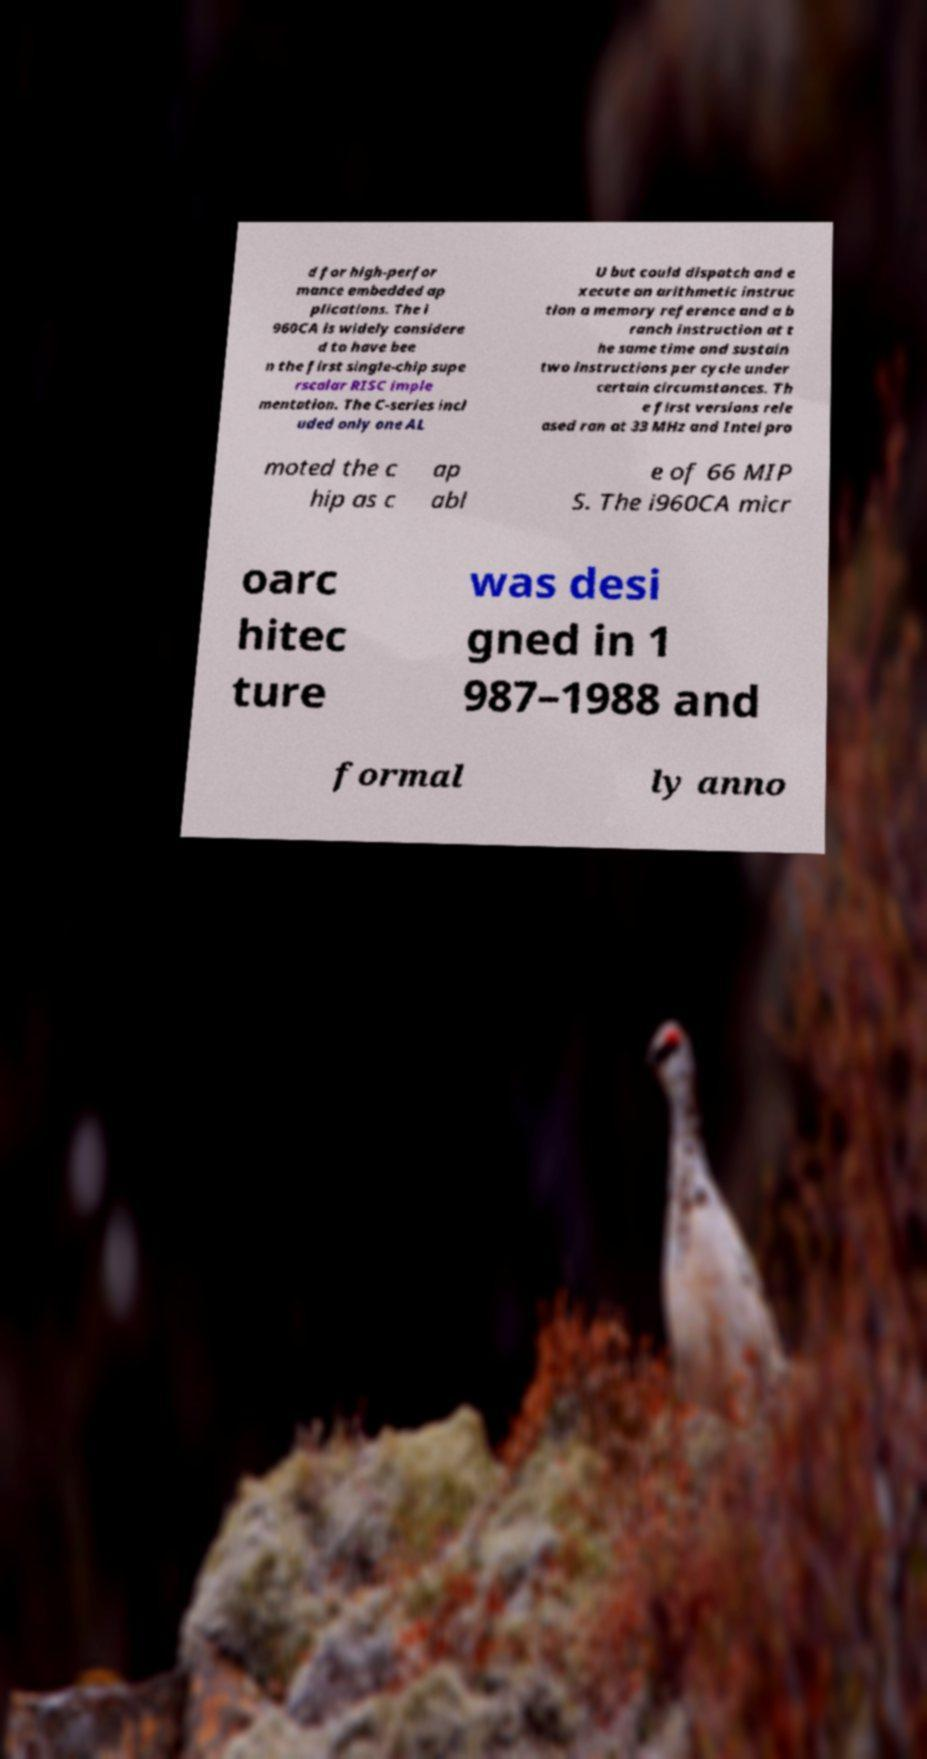Please identify and transcribe the text found in this image. d for high-perfor mance embedded ap plications. The i 960CA is widely considere d to have bee n the first single-chip supe rscalar RISC imple mentation. The C-series incl uded only one AL U but could dispatch and e xecute an arithmetic instruc tion a memory reference and a b ranch instruction at t he same time and sustain two instructions per cycle under certain circumstances. Th e first versions rele ased ran at 33 MHz and Intel pro moted the c hip as c ap abl e of 66 MIP S. The i960CA micr oarc hitec ture was desi gned in 1 987–1988 and formal ly anno 